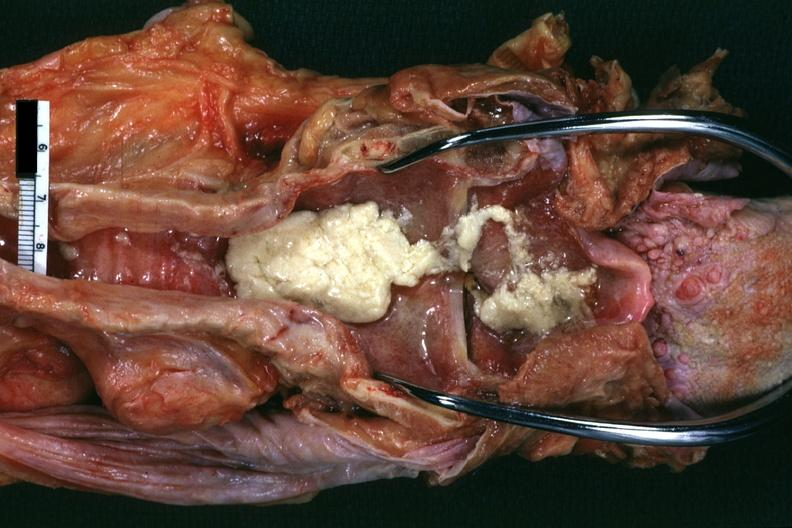s lateral view present?
Answer the question using a single word or phrase. No 